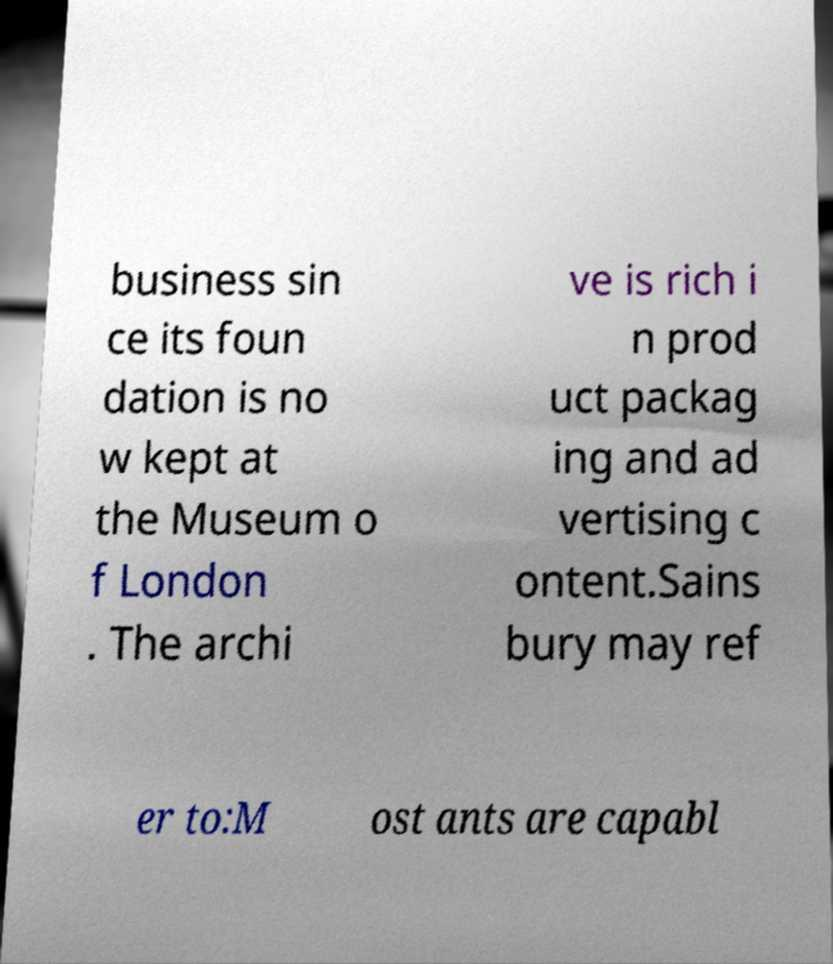There's text embedded in this image that I need extracted. Can you transcribe it verbatim? business sin ce its foun dation is no w kept at the Museum o f London . The archi ve is rich i n prod uct packag ing and ad vertising c ontent.Sains bury may ref er to:M ost ants are capabl 